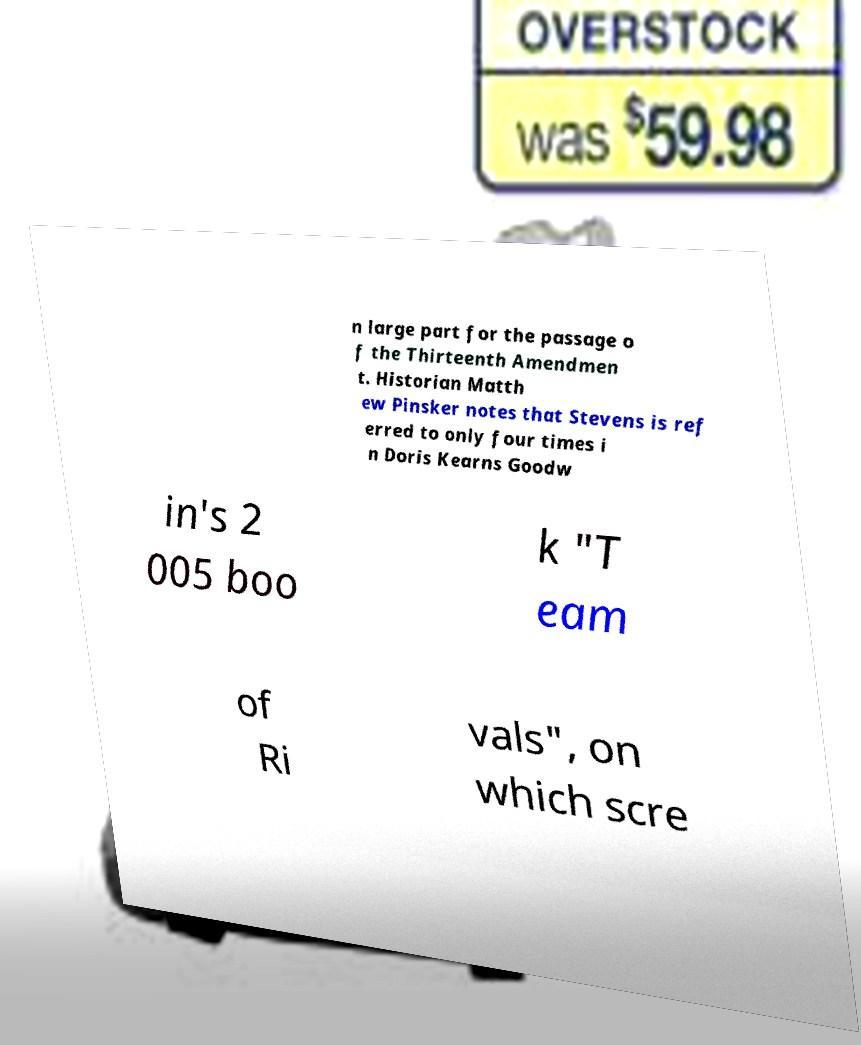Can you read and provide the text displayed in the image?This photo seems to have some interesting text. Can you extract and type it out for me? n large part for the passage o f the Thirteenth Amendmen t. Historian Matth ew Pinsker notes that Stevens is ref erred to only four times i n Doris Kearns Goodw in's 2 005 boo k "T eam of Ri vals", on which scre 